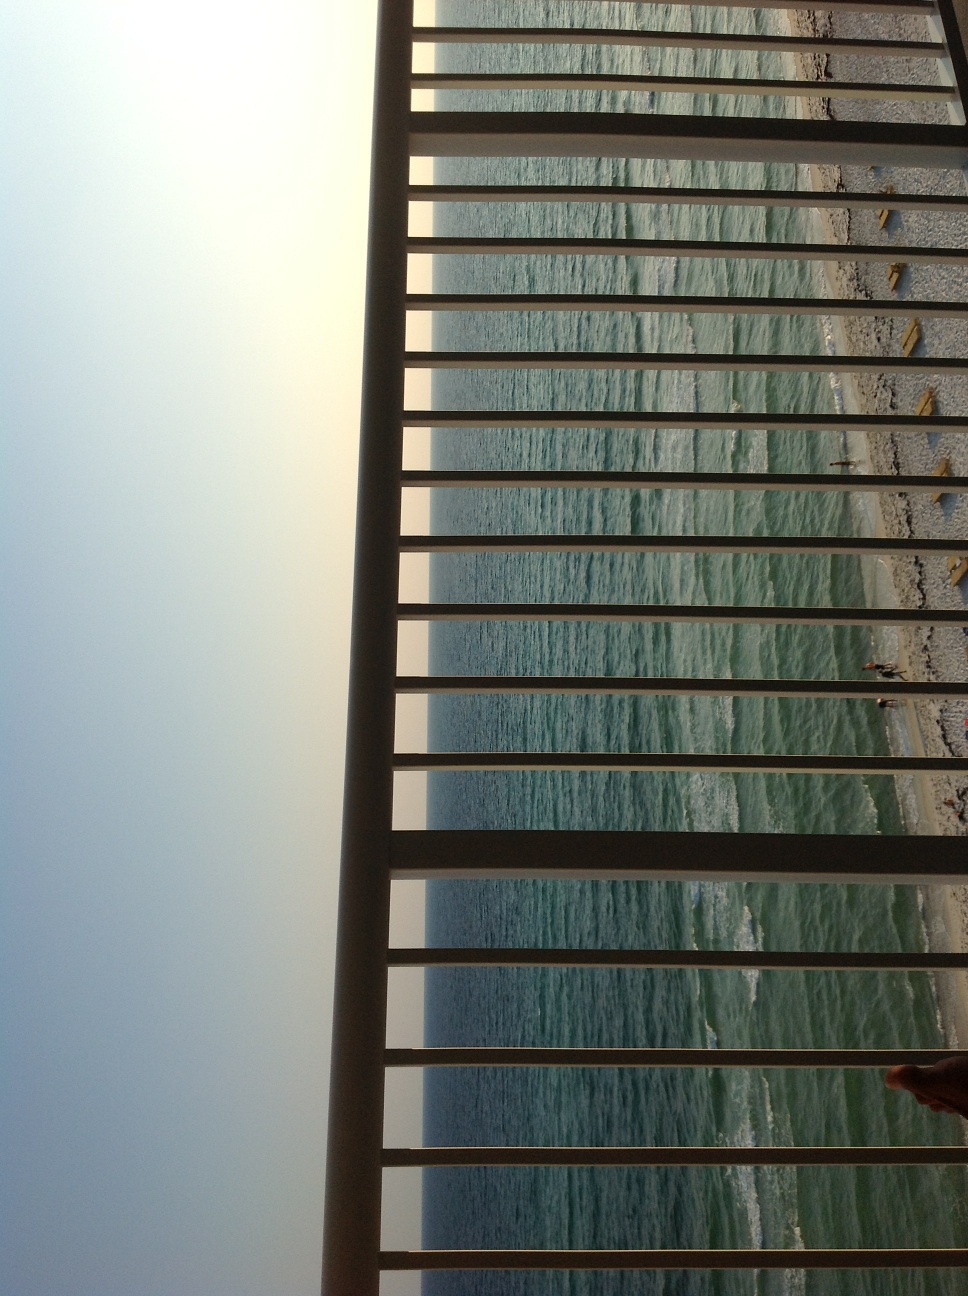What is the mood or feeling evoked by this setting? The setting evokes a mood of serenity and contemplation. The combination of the rhythmic waves, tranquil sea, and the enclosing bars of the railing blend to create a contemplative space, suggesting solitude and introspective moments by the sea. 